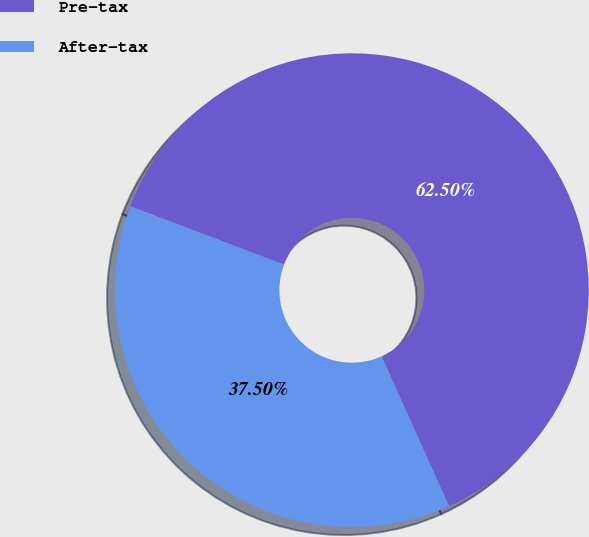Convert chart to OTSL. <chart><loc_0><loc_0><loc_500><loc_500><pie_chart><fcel>Pre-tax<fcel>After-tax<nl><fcel>62.5%<fcel>37.5%<nl></chart> 